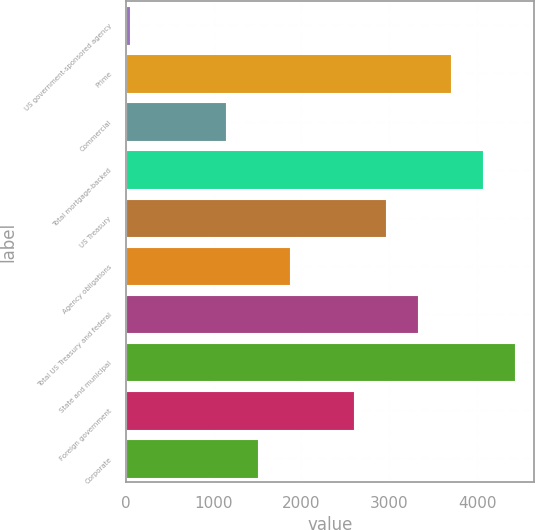Convert chart. <chart><loc_0><loc_0><loc_500><loc_500><bar_chart><fcel>US government-sponsored agency<fcel>Prime<fcel>Commercial<fcel>Total mortgage-backed<fcel>US Treasury<fcel>Agency obligations<fcel>Total US Treasury and federal<fcel>State and municipal<fcel>Foreign government<fcel>Corporate<nl><fcel>50<fcel>3698<fcel>1144.4<fcel>4062.8<fcel>2968.4<fcel>1874<fcel>3333.2<fcel>4427.6<fcel>2603.6<fcel>1509.2<nl></chart> 